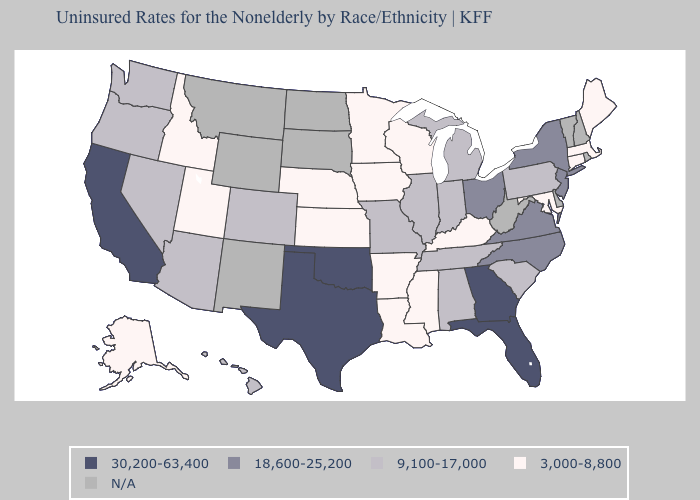Does Wisconsin have the highest value in the USA?
Quick response, please. No. Is the legend a continuous bar?
Write a very short answer. No. Among the states that border Delaware , does Pennsylvania have the highest value?
Short answer required. No. What is the value of Arizona?
Keep it brief. 9,100-17,000. Among the states that border Connecticut , which have the lowest value?
Write a very short answer. Massachusetts. Name the states that have a value in the range 30,200-63,400?
Write a very short answer. California, Florida, Georgia, Oklahoma, Texas. Among the states that border Georgia , does Alabama have the lowest value?
Concise answer only. Yes. What is the lowest value in states that border Vermont?
Concise answer only. 3,000-8,800. Does the first symbol in the legend represent the smallest category?
Give a very brief answer. No. Does Mississippi have the lowest value in the USA?
Short answer required. Yes. Among the states that border Arizona , which have the highest value?
Keep it brief. California. What is the highest value in the USA?
Give a very brief answer. 30,200-63,400. Which states have the lowest value in the South?
Write a very short answer. Arkansas, Kentucky, Louisiana, Maryland, Mississippi. 